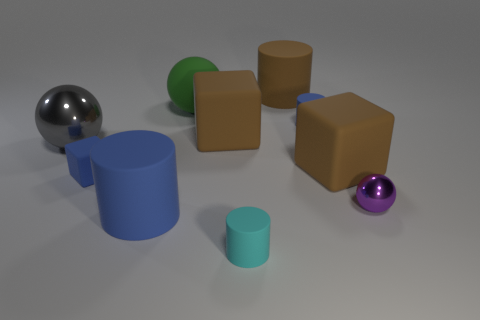There is a matte cylinder that is both right of the matte sphere and in front of the small purple shiny ball; what is its size?
Ensure brevity in your answer.  Small. There is a big cylinder on the left side of the big green matte thing; is it the same color as the tiny matte block?
Provide a succinct answer. Yes. Is the number of small purple metal objects to the left of the big green ball less than the number of big cyan matte objects?
Ensure brevity in your answer.  No. What shape is the cyan object that is the same material as the big blue object?
Offer a terse response. Cylinder. Do the purple object and the small blue cylinder have the same material?
Provide a short and direct response. No. Are there fewer tiny blue rubber blocks on the left side of the large gray thing than small blue rubber objects that are to the left of the tiny cyan matte object?
Provide a succinct answer. Yes. There is a large blue matte cylinder that is in front of the ball in front of the big gray metallic sphere; how many metallic balls are in front of it?
Your answer should be compact. 0. Do the tiny shiny thing and the small matte block have the same color?
Provide a succinct answer. No. Is there a metal cylinder that has the same color as the tiny shiny sphere?
Ensure brevity in your answer.  No. The ball that is the same size as the gray metal thing is what color?
Your response must be concise. Green. 